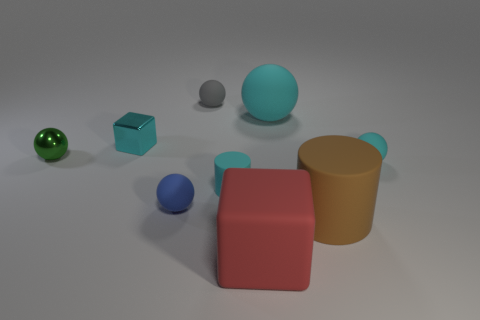Which objects in the image are closest to each other? The closest objects to each other appear to be the smaller blue sphere and the blue metallic block, which are nearly touching. 